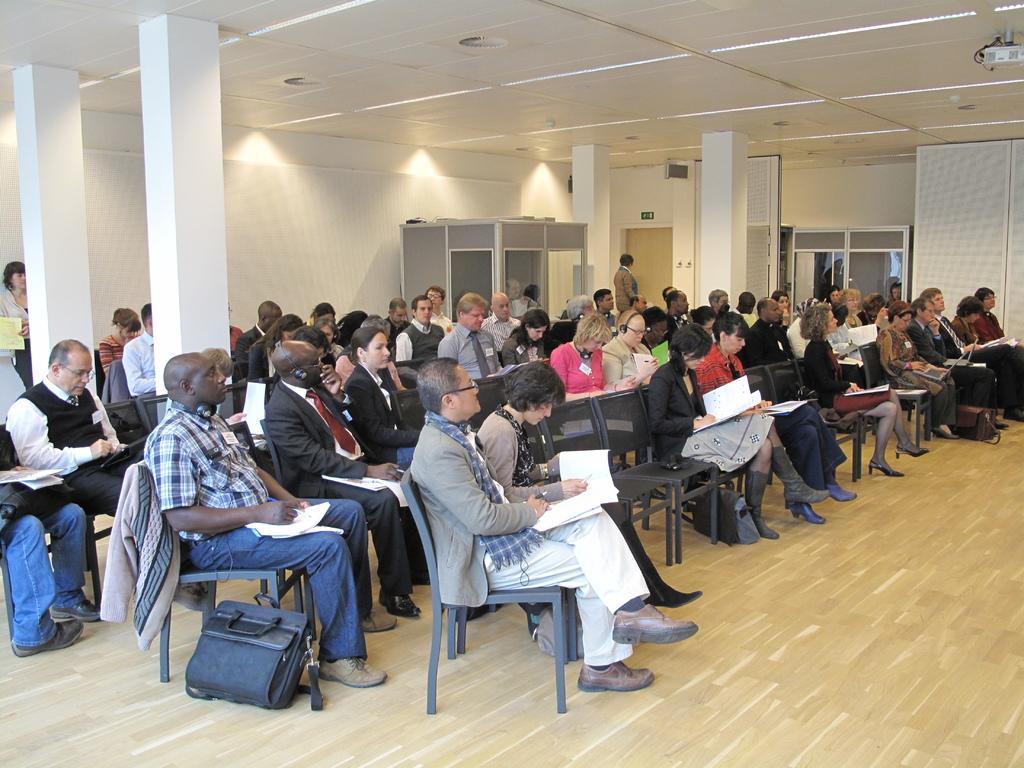How would you summarize this image in a sentence or two? people are seated on the chairs in a room. they are holding a book in their hand. in the 2 row there is a laptop bag present on the floor. on the top right there is projector. there are 4 white pillars. at the back there are 2 people standing at the right and left of the room. 